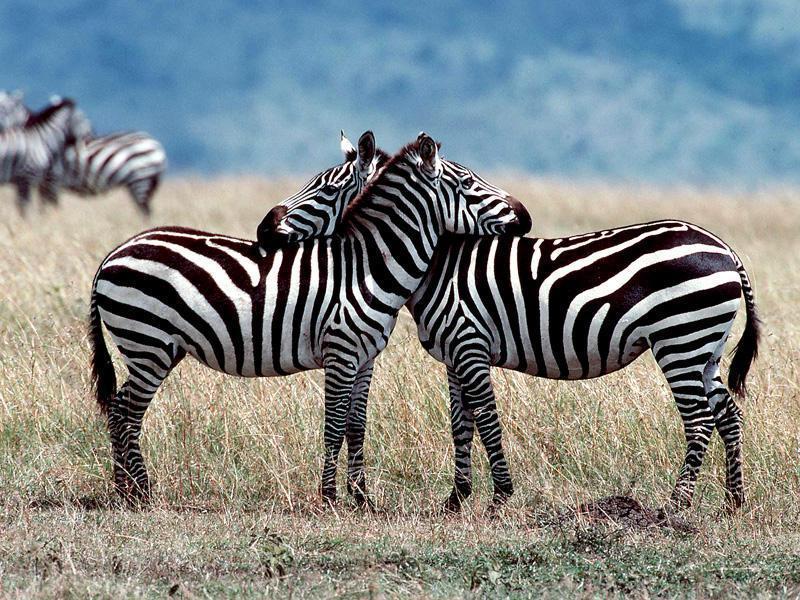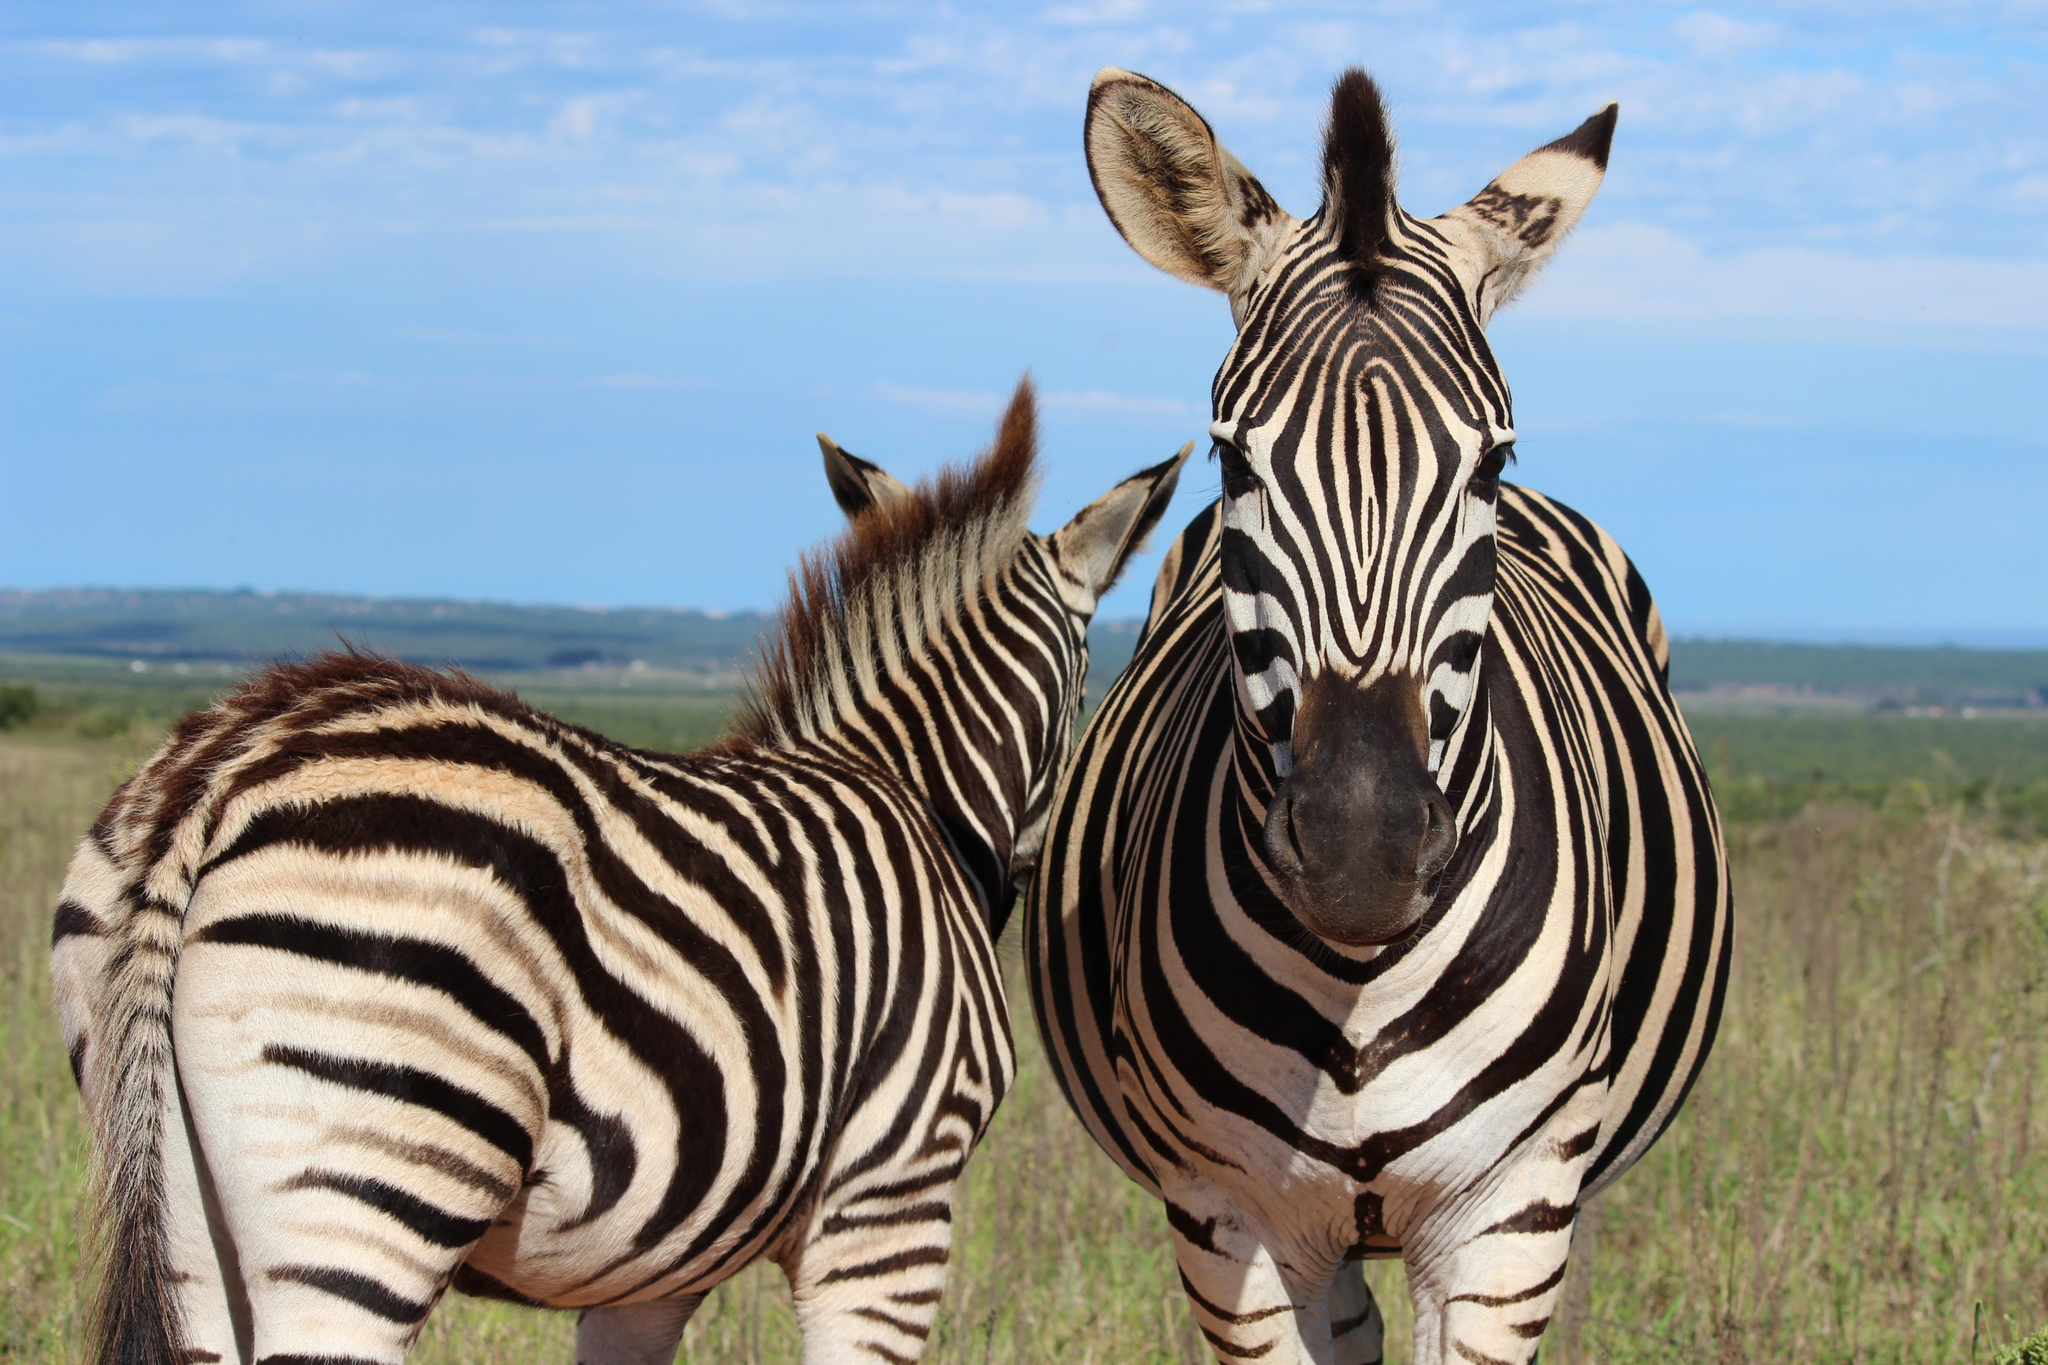The first image is the image on the left, the second image is the image on the right. Considering the images on both sides, is "There are two zebras with there noses on the arch of the other zebras back." valid? Answer yes or no. Yes. The first image is the image on the left, the second image is the image on the right. For the images shown, is this caption "The left image shows a right-turned zebra standing closest to the camera, with its head resting on the shoulders of a left-turned zebra, and the left-turned zebra with its head resting on the shoulders of the right-turned zebra." true? Answer yes or no. Yes. 